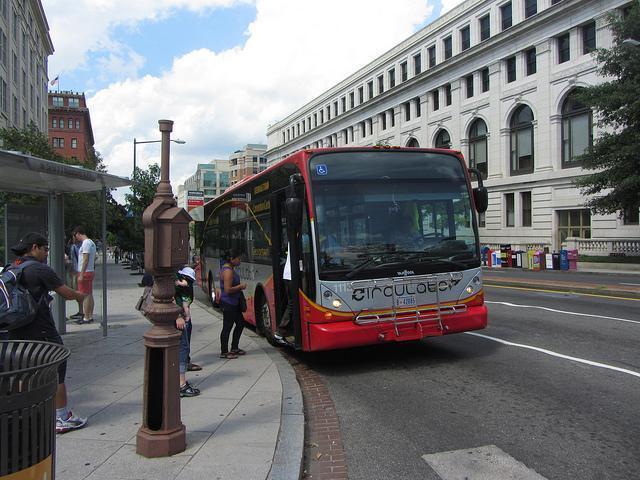What special group of people are accommodated in the bus?
Choose the right answer from the provided options to respond to the question.
Options: Pregnant women, blind, handicapped, elderly. Handicapped. 